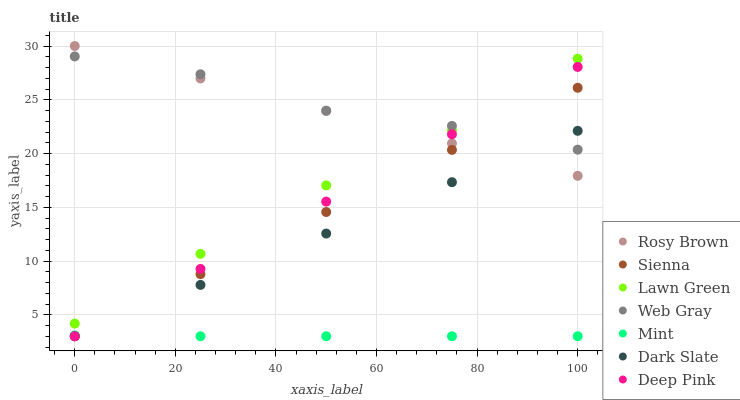Does Mint have the minimum area under the curve?
Answer yes or no. Yes. Does Web Gray have the maximum area under the curve?
Answer yes or no. Yes. Does Rosy Brown have the minimum area under the curve?
Answer yes or no. No. Does Rosy Brown have the maximum area under the curve?
Answer yes or no. No. Is Rosy Brown the smoothest?
Answer yes or no. Yes. Is Web Gray the roughest?
Answer yes or no. Yes. Is Web Gray the smoothest?
Answer yes or no. No. Is Rosy Brown the roughest?
Answer yes or no. No. Does Sienna have the lowest value?
Answer yes or no. Yes. Does Rosy Brown have the lowest value?
Answer yes or no. No. Does Rosy Brown have the highest value?
Answer yes or no. Yes. Does Web Gray have the highest value?
Answer yes or no. No. Is Sienna less than Lawn Green?
Answer yes or no. Yes. Is Lawn Green greater than Dark Slate?
Answer yes or no. Yes. Does Sienna intersect Dark Slate?
Answer yes or no. Yes. Is Sienna less than Dark Slate?
Answer yes or no. No. Is Sienna greater than Dark Slate?
Answer yes or no. No. Does Sienna intersect Lawn Green?
Answer yes or no. No. 